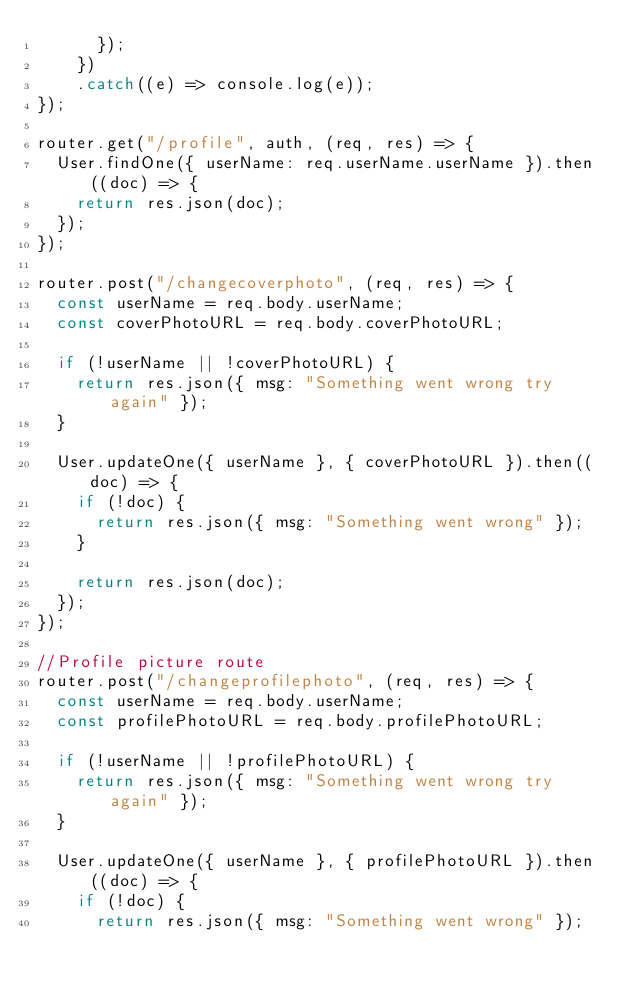Convert code to text. <code><loc_0><loc_0><loc_500><loc_500><_JavaScript_>      });
    })
    .catch((e) => console.log(e));
});

router.get("/profile", auth, (req, res) => {
  User.findOne({ userName: req.userName.userName }).then((doc) => {
    return res.json(doc);
  });
});

router.post("/changecoverphoto", (req, res) => {
  const userName = req.body.userName;
  const coverPhotoURL = req.body.coverPhotoURL;

  if (!userName || !coverPhotoURL) {
    return res.json({ msg: "Something went wrong try again" });
  }

  User.updateOne({ userName }, { coverPhotoURL }).then((doc) => {
    if (!doc) {
      return res.json({ msg: "Something went wrong" });
    }

    return res.json(doc);
  });
});

//Profile picture route
router.post("/changeprofilephoto", (req, res) => {
  const userName = req.body.userName;
  const profilePhotoURL = req.body.profilePhotoURL;

  if (!userName || !profilePhotoURL) {
    return res.json({ msg: "Something went wrong try again" });
  }

  User.updateOne({ userName }, { profilePhotoURL }).then((doc) => {
    if (!doc) {
      return res.json({ msg: "Something went wrong" });</code> 